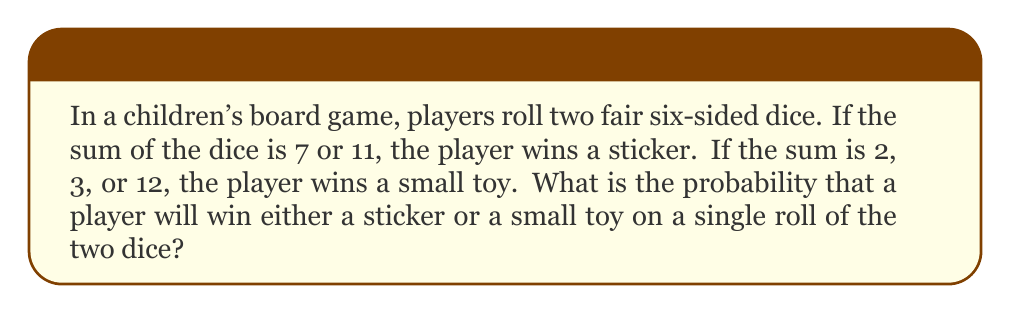Could you help me with this problem? Let's approach this step-by-step:

1) First, we need to calculate the total number of possible outcomes when rolling two dice. Each die has 6 possible outcomes, so the total number of outcomes is:

   $6 \times 6 = 36$

2) Now, let's calculate the probability of winning a sticker:
   - A sum of 7 can be achieved in 6 ways: (1,6), (2,5), (3,4), (4,3), (5,2), (6,1)
   - A sum of 11 can be achieved in 2 ways: (5,6), (6,5)
   
   So, there are 8 favorable outcomes for winning a sticker.
   
   $P(\text{sticker}) = \frac{8}{36} = \frac{2}{9}$

3) Next, let's calculate the probability of winning a small toy:
   - A sum of 2 can be achieved in 1 way: (1,1)
   - A sum of 3 can be achieved in 2 ways: (1,2), (2,1)
   - A sum of 12 can be achieved in 1 way: (6,6)
   
   So, there are 4 favorable outcomes for winning a small toy.
   
   $P(\text{toy}) = \frac{4}{36} = \frac{1}{9}$

4) The probability of winning either a sticker or a small toy is the sum of these probabilities, as the events are mutually exclusive (you can't win both on a single roll):

   $P(\text{sticker or toy}) = P(\text{sticker}) + P(\text{toy}) = \frac{2}{9} + \frac{1}{9} = \frac{3}{9} = \frac{1}{3}$

Therefore, the probability of winning either a sticker or a small toy on a single roll is $\frac{1}{3}$.
Answer: $\frac{1}{3}$ 